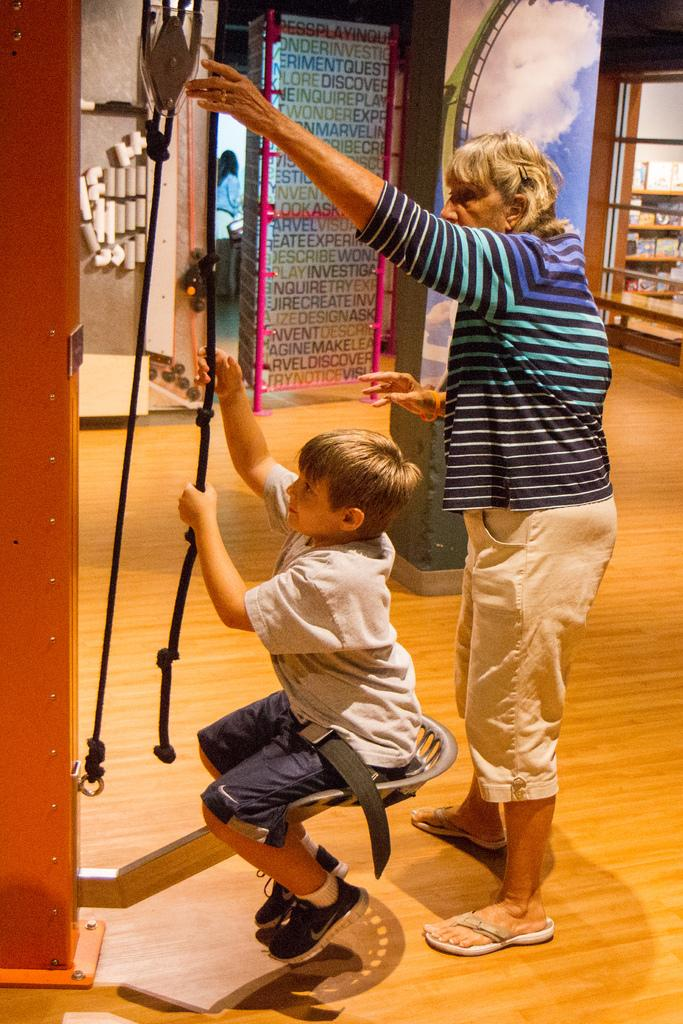How many people are in the image? There are people in the image, but the exact number is not specified. Can you describe the position of the boy in the image? The boy is seated in the middle of the image. What is the boy holding in the image? The boy is holding a rope. What type of shoes is the ladybug wearing in the image? There is no ladybug or shoes present in the image. 